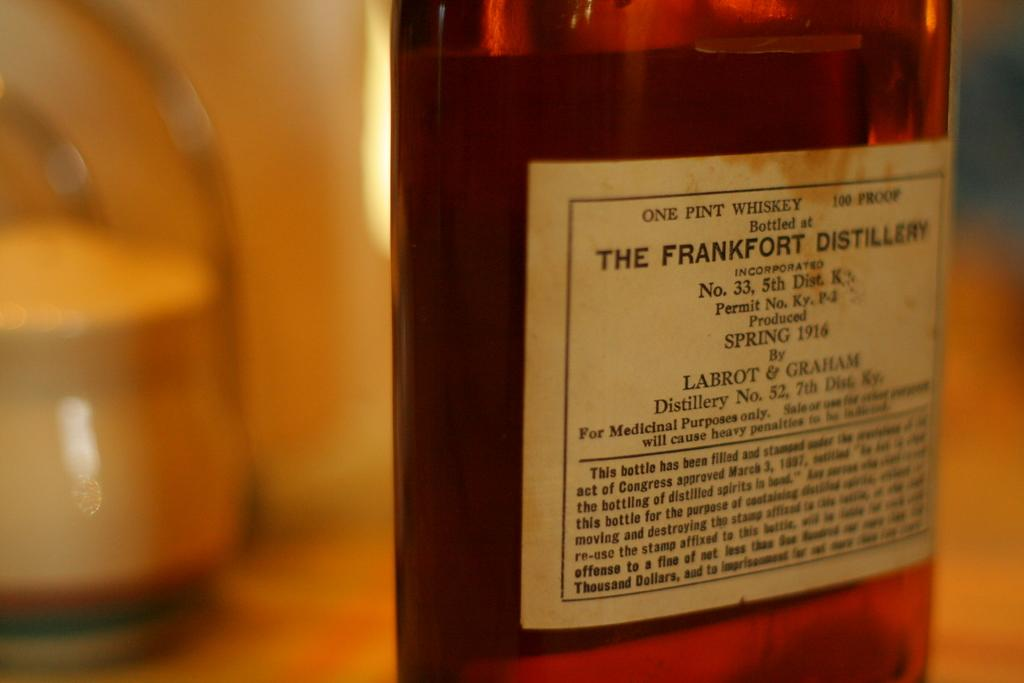<image>
Offer a succinct explanation of the picture presented. The label of a bottle of whiskey from the Frankfort Distillery is yellowing and stained. 